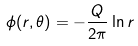<formula> <loc_0><loc_0><loc_500><loc_500>\phi ( r , \theta ) = - \frac { Q } { 2 \pi } \ln r</formula> 